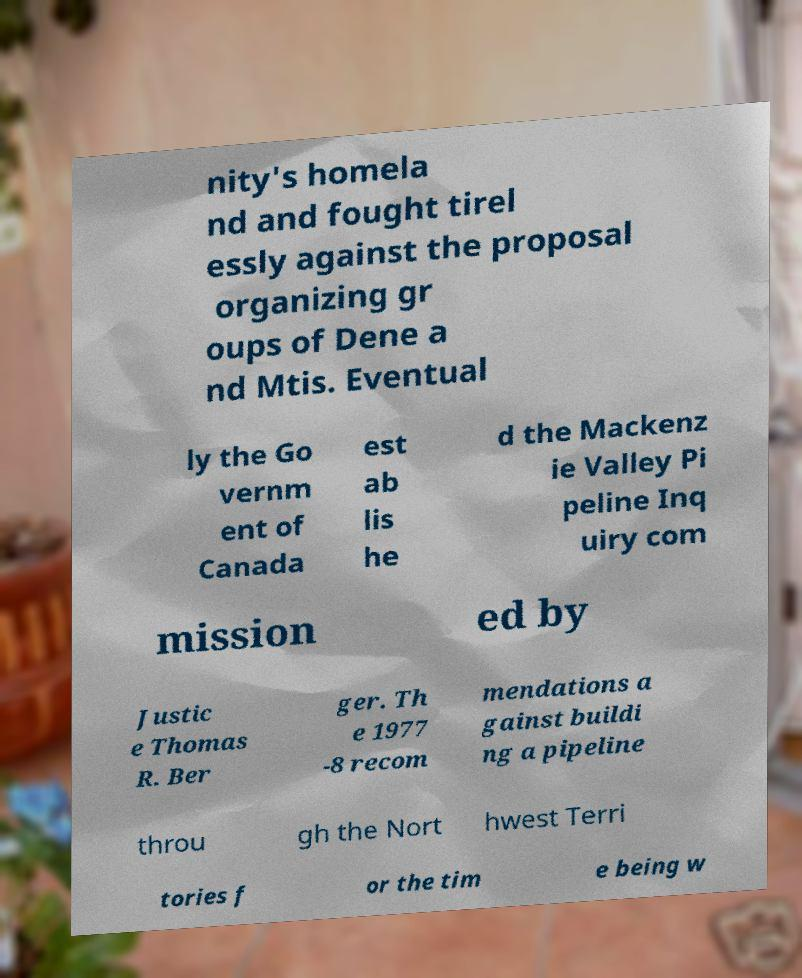Can you read and provide the text displayed in the image?This photo seems to have some interesting text. Can you extract and type it out for me? nity's homela nd and fought tirel essly against the proposal organizing gr oups of Dene a nd Mtis. Eventual ly the Go vernm ent of Canada est ab lis he d the Mackenz ie Valley Pi peline Inq uiry com mission ed by Justic e Thomas R. Ber ger. Th e 1977 -8 recom mendations a gainst buildi ng a pipeline throu gh the Nort hwest Terri tories f or the tim e being w 